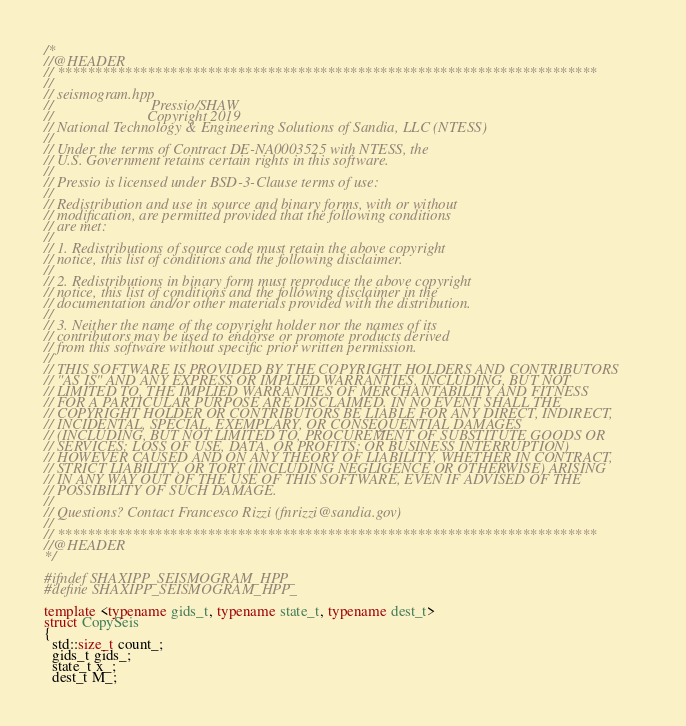<code> <loc_0><loc_0><loc_500><loc_500><_C++_>/*
//@HEADER
// ************************************************************************
//
// seismogram.hpp
//                     		Pressio/SHAW
//                         Copyright 2019
// National Technology & Engineering Solutions of Sandia, LLC (NTESS)
//
// Under the terms of Contract DE-NA0003525 with NTESS, the
// U.S. Government retains certain rights in this software.
//
// Pressio is licensed under BSD-3-Clause terms of use:
//
// Redistribution and use in source and binary forms, with or without
// modification, are permitted provided that the following conditions
// are met:
//
// 1. Redistributions of source code must retain the above copyright
// notice, this list of conditions and the following disclaimer.
//
// 2. Redistributions in binary form must reproduce the above copyright
// notice, this list of conditions and the following disclaimer in the
// documentation and/or other materials provided with the distribution.
//
// 3. Neither the name of the copyright holder nor the names of its
// contributors may be used to endorse or promote products derived
// from this software without specific prior written permission.
//
// THIS SOFTWARE IS PROVIDED BY THE COPYRIGHT HOLDERS AND CONTRIBUTORS
// "AS IS" AND ANY EXPRESS OR IMPLIED WARRANTIES, INCLUDING, BUT NOT
// LIMITED TO, THE IMPLIED WARRANTIES OF MERCHANTABILITY AND FITNESS
// FOR A PARTICULAR PURPOSE ARE DISCLAIMED. IN NO EVENT SHALL THE
// COPYRIGHT HOLDER OR CONTRIBUTORS BE LIABLE FOR ANY DIRECT, INDIRECT,
// INCIDENTAL, SPECIAL, EXEMPLARY, OR CONSEQUENTIAL DAMAGES
// (INCLUDING, BUT NOT LIMITED TO, PROCUREMENT OF SUBSTITUTE GOODS OR
// SERVICES; LOSS OF USE, DATA, OR PROFITS; OR BUSINESS INTERRUPTION)
// HOWEVER CAUSED AND ON ANY THEORY OF LIABILITY, WHETHER IN CONTRACT,
// STRICT LIABILITY, OR TORT (INCLUDING NEGLIGENCE OR OTHERWISE) ARISING
// IN ANY WAY OUT OF THE USE OF THIS SOFTWARE, EVEN IF ADVISED OF THE
// POSSIBILITY OF SUCH DAMAGE.
//
// Questions? Contact Francesco Rizzi (fnrizzi@sandia.gov)
//
// ************************************************************************
//@HEADER
*/

#ifndef SHAXIPP_SEISMOGRAM_HPP_
#define SHAXIPP_SEISMOGRAM_HPP_

template <typename gids_t, typename state_t, typename dest_t>
struct CopySeis
{
  std::size_t count_;
  gids_t gids_;
  state_t x_;
  dest_t M_;
</code> 